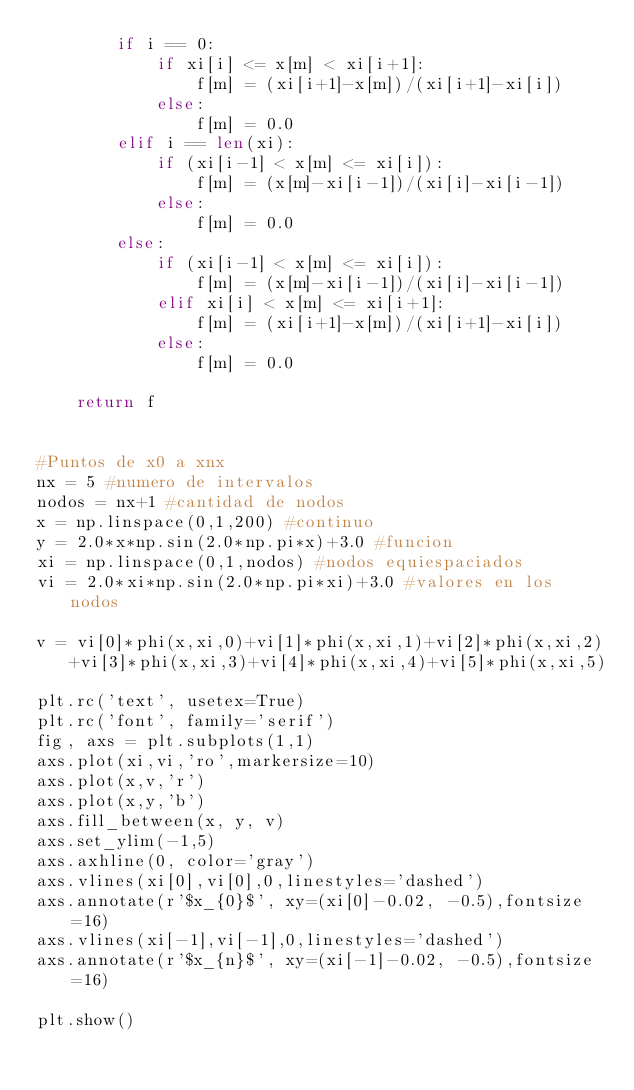<code> <loc_0><loc_0><loc_500><loc_500><_Python_>        if i == 0:
            if xi[i] <= x[m] < xi[i+1]:
                f[m] = (xi[i+1]-x[m])/(xi[i+1]-xi[i])
            else:
                f[m] = 0.0        
        elif i == len(xi):
            if (xi[i-1] < x[m] <= xi[i]):
                f[m] = (x[m]-xi[i-1])/(xi[i]-xi[i-1])
            else:
                f[m] = 0.0
        else:
            if (xi[i-1] < x[m] <= xi[i]):
                f[m] = (x[m]-xi[i-1])/(xi[i]-xi[i-1])
            elif xi[i] < x[m] <= xi[i+1]:
                f[m] = (xi[i+1]-x[m])/(xi[i+1]-xi[i])
            else:
                f[m] = 0.0
        
    return f


#Puntos de x0 a xnx
nx = 5 #numero de intervalos
nodos = nx+1 #cantidad de nodos
x = np.linspace(0,1,200) #continuo
y = 2.0*x*np.sin(2.0*np.pi*x)+3.0 #funcion
xi = np.linspace(0,1,nodos) #nodos equiespaciados
vi = 2.0*xi*np.sin(2.0*np.pi*xi)+3.0 #valores en los nodos

v = vi[0]*phi(x,xi,0)+vi[1]*phi(x,xi,1)+vi[2]*phi(x,xi,2)+vi[3]*phi(x,xi,3)+vi[4]*phi(x,xi,4)+vi[5]*phi(x,xi,5)

plt.rc('text', usetex=True)
plt.rc('font', family='serif')
fig, axs = plt.subplots(1,1)
axs.plot(xi,vi,'ro',markersize=10)
axs.plot(x,v,'r')
axs.plot(x,y,'b')
axs.fill_between(x, y, v)
axs.set_ylim(-1,5)
axs.axhline(0, color='gray')
axs.vlines(xi[0],vi[0],0,linestyles='dashed')
axs.annotate(r'$x_{0}$', xy=(xi[0]-0.02, -0.5),fontsize=16)
axs.vlines(xi[-1],vi[-1],0,linestyles='dashed')
axs.annotate(r'$x_{n}$', xy=(xi[-1]-0.02, -0.5),fontsize=16)

plt.show()



</code> 